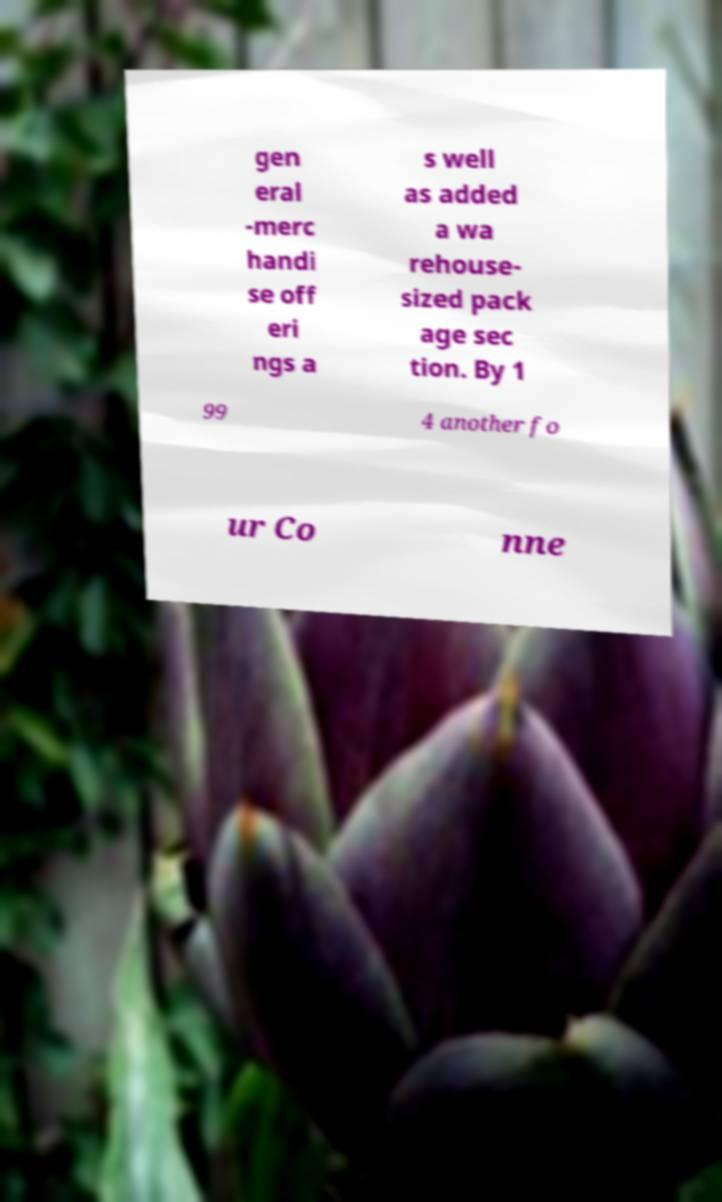Could you assist in decoding the text presented in this image and type it out clearly? gen eral -merc handi se off eri ngs a s well as added a wa rehouse- sized pack age sec tion. By 1 99 4 another fo ur Co nne 